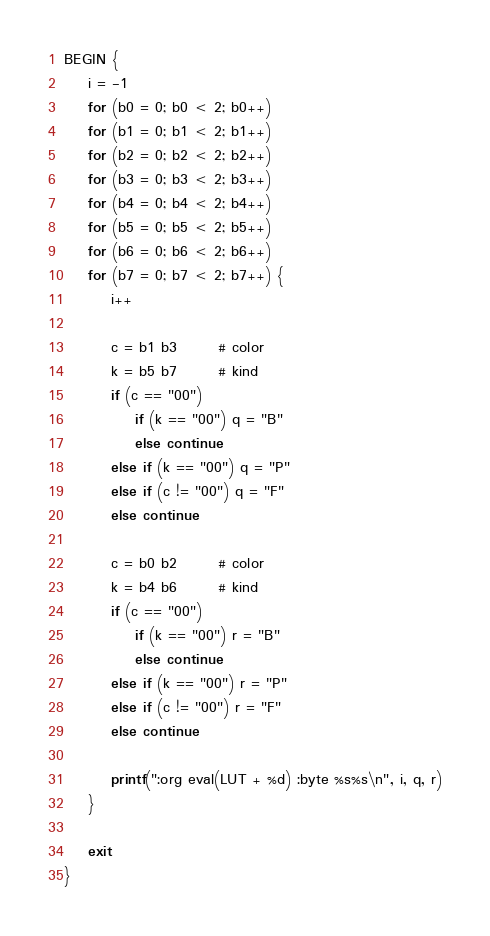<code> <loc_0><loc_0><loc_500><loc_500><_Awk_>
BEGIN {
	i = -1
	for (b0 = 0; b0 < 2; b0++)
	for (b1 = 0; b1 < 2; b1++)
	for (b2 = 0; b2 < 2; b2++)
	for (b3 = 0; b3 < 2; b3++)
	for (b4 = 0; b4 < 2; b4++)
	for (b5 = 0; b5 < 2; b5++)
	for (b6 = 0; b6 < 2; b6++)
	for (b7 = 0; b7 < 2; b7++) {
		i++

		c = b1 b3       # color
		k = b5 b7       # kind
		if (c == "00") 
			if (k == "00") q = "B"
			else continue
		else if (k == "00") q = "P"
		else if (c != "00") q = "F"
		else continue

		c = b0 b2       # color
		k = b4 b6       # kind
		if (c == "00") 
			if (k == "00") r = "B"
			else continue
		else if (k == "00") r = "P"
		else if (c != "00") r = "F"
		else continue

		printf(":org eval(LUT + %d) :byte %s%s\n", i, q, r)
	}

	exit
}
</code> 